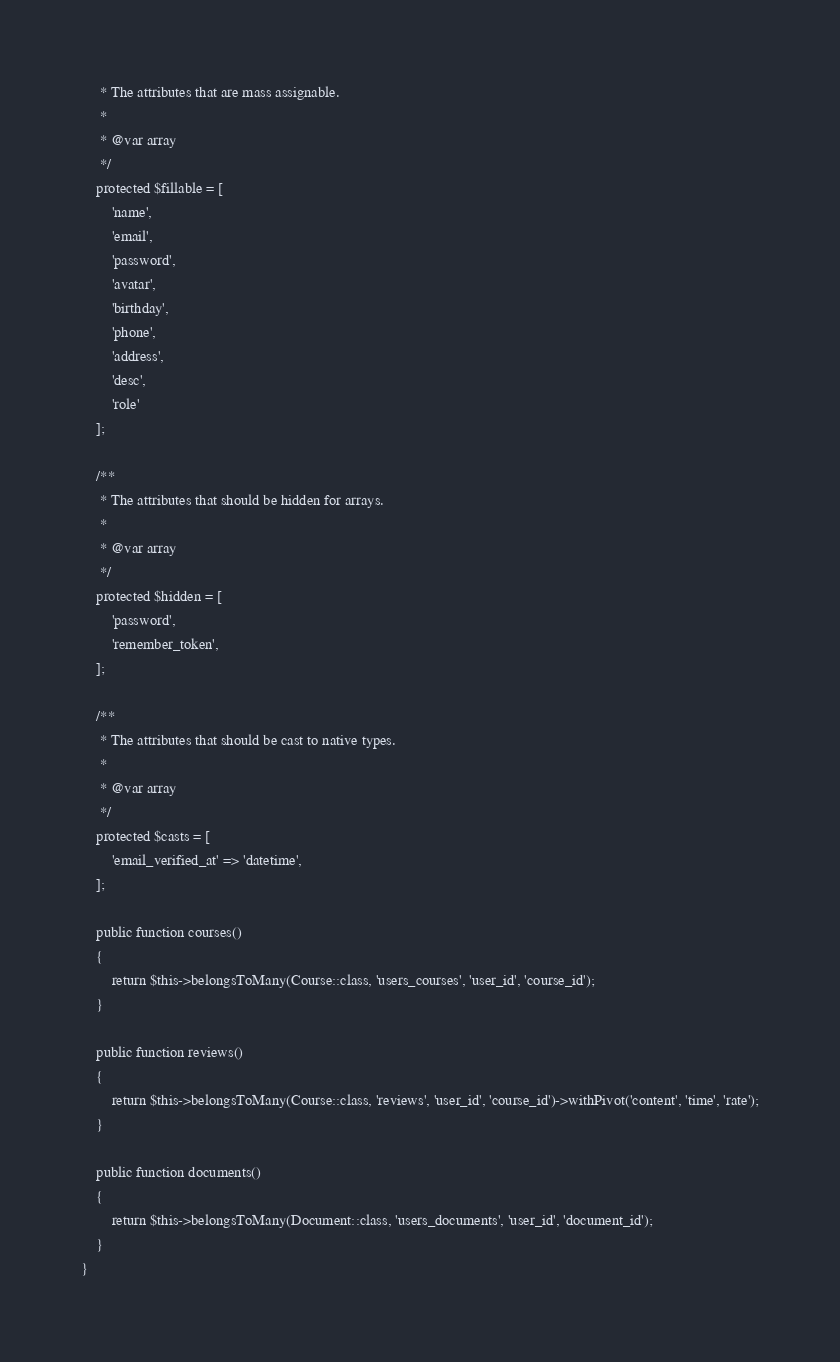<code> <loc_0><loc_0><loc_500><loc_500><_PHP_>     * The attributes that are mass assignable.
     *
     * @var array
     */
    protected $fillable = [
        'name',
        'email',
        'password',
        'avatar',
        'birthday',
        'phone',
        'address',
        'desc',
        'role'
    ];

    /**
     * The attributes that should be hidden for arrays.
     *
     * @var array
     */
    protected $hidden = [
        'password',
        'remember_token',
    ];

    /**
     * The attributes that should be cast to native types.
     *
     * @var array
     */
    protected $casts = [
        'email_verified_at' => 'datetime',
    ];

    public function courses()
    {
        return $this->belongsToMany(Course::class, 'users_courses', 'user_id', 'course_id');
    }

    public function reviews()
    {
        return $this->belongsToMany(Course::class, 'reviews', 'user_id', 'course_id')->withPivot('content', 'time', 'rate');
    }

    public function documents()
    {
        return $this->belongsToMany(Document::class, 'users_documents', 'user_id', 'document_id');
    }
}
</code> 